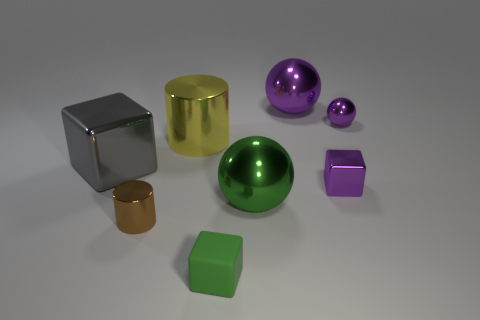Are there any other things that are the same material as the green cube?
Provide a succinct answer. No. What is the material of the big object that is the same color as the small rubber block?
Ensure brevity in your answer.  Metal. How many balls are the same size as the matte thing?
Offer a terse response. 1. The small metal object that is the same color as the tiny shiny block is what shape?
Keep it short and to the point. Sphere. What is the material of the cylinder that is right of the brown metal cylinder?
Make the answer very short. Metal. What number of other objects are the same shape as the large green shiny thing?
Make the answer very short. 2. There is a yellow thing that is made of the same material as the big purple sphere; what is its shape?
Your answer should be very brief. Cylinder. What shape is the large yellow shiny thing that is left of the tiny block that is left of the large metallic sphere behind the small purple metallic sphere?
Your answer should be compact. Cylinder. Are there more gray things than tiny yellow shiny objects?
Your answer should be compact. Yes. What material is the brown object that is the same shape as the big yellow object?
Offer a terse response. Metal. 